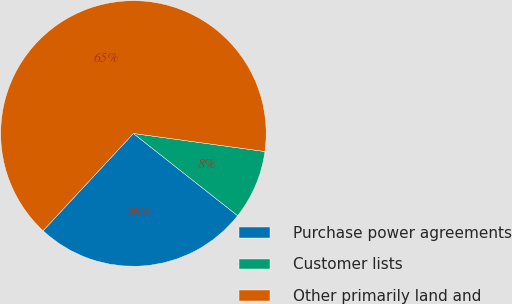Convert chart. <chart><loc_0><loc_0><loc_500><loc_500><pie_chart><fcel>Purchase power agreements<fcel>Customer lists<fcel>Other primarily land and<nl><fcel>26.28%<fcel>8.46%<fcel>65.26%<nl></chart> 